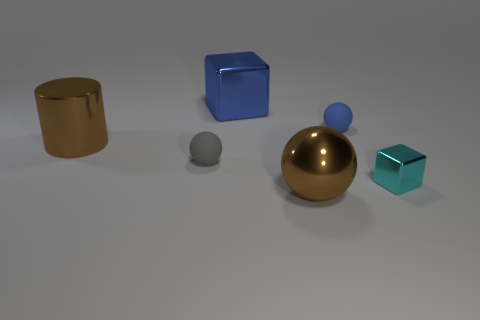What number of objects are either metal cubes or purple rubber objects?
Your answer should be compact. 2. Is there a brown cylinder that has the same size as the cyan block?
Provide a succinct answer. No. There is a large blue thing; what shape is it?
Provide a short and direct response. Cube. Are there more metallic objects on the left side of the big shiny cylinder than metallic blocks left of the gray rubber thing?
Your answer should be compact. No. Is the color of the small thing that is on the left side of the big brown ball the same as the metal cube right of the brown sphere?
Provide a succinct answer. No. The gray object that is the same size as the cyan metallic object is what shape?
Give a very brief answer. Sphere. Are there any other tiny metallic things that have the same shape as the small shiny thing?
Your response must be concise. No. Do the big thing that is right of the large blue thing and the blue thing in front of the large blue metal cube have the same material?
Your response must be concise. No. There is a tiny thing that is the same color as the large metal cube; what is its shape?
Keep it short and to the point. Sphere. What number of tiny cyan spheres are made of the same material as the tiny cyan object?
Give a very brief answer. 0. 